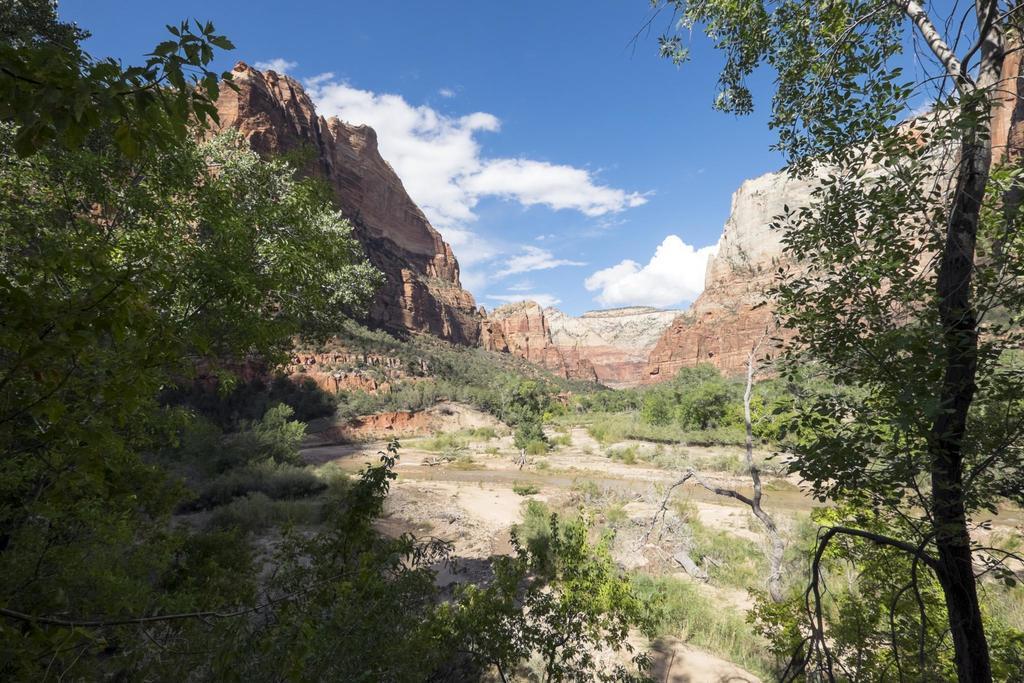Could you give a brief overview of what you see in this image? In the image we can see the trees and grass. Here we can see the rocks and the cloudy sky. 